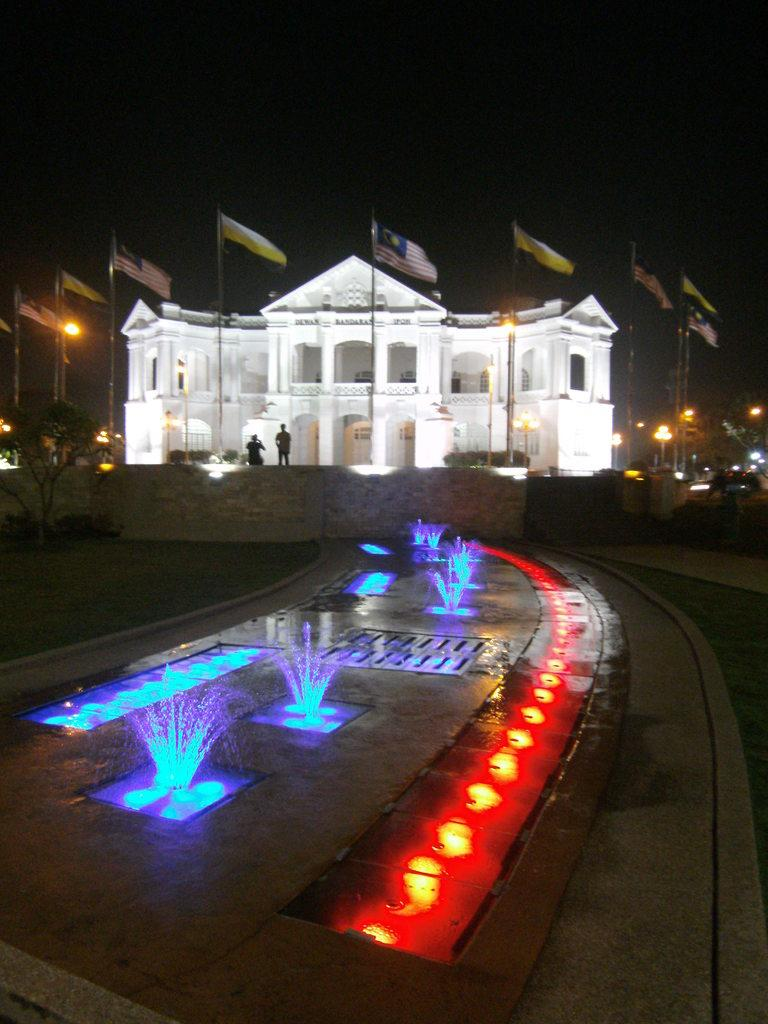What type of structures are present in the image? There are water fountains, lights, flags with poles, and a building in the image. What type of vegetation is present in the image? There are trees in the image. How many people are in the image? There are two persons in the image. What is the color of the background in the image? The background of the image is dark. What is the aftermath of the forceful respect shown by the trees in the image? There is no mention of force or respect in the image, nor are there any trees exhibiting such behavior. 